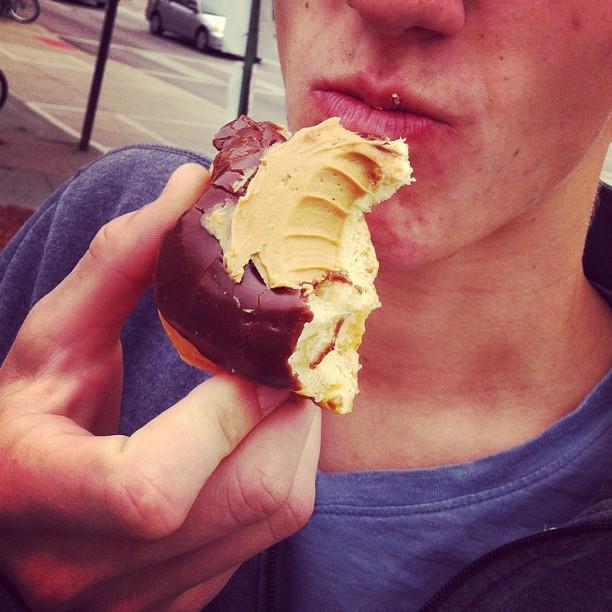Is "The donut is touching the person." an appropriate description for the image?
Answer yes or no. Yes. 